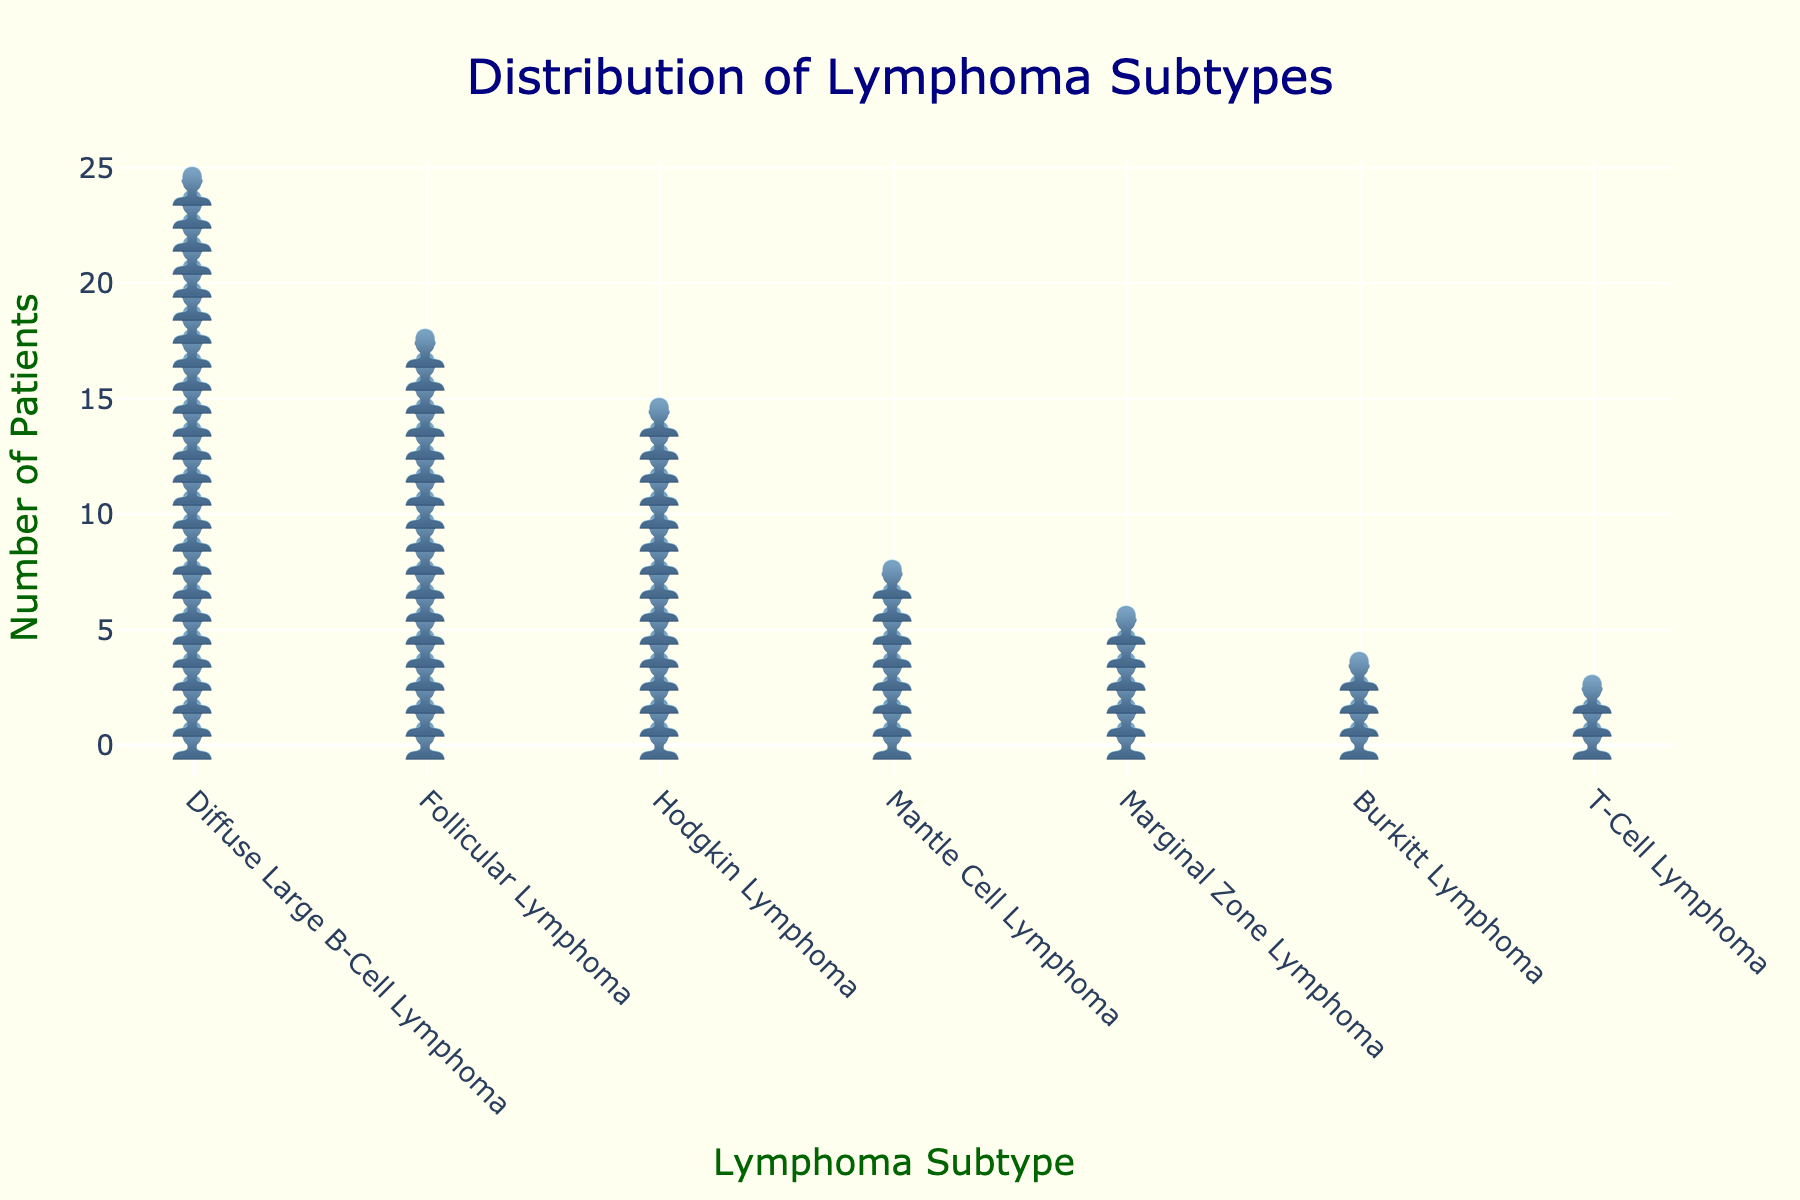What is the most common subtype of lymphoma among patients in the oncology department? The tallest cluster of icons represents the most common subtype. The highest cluster is for Diffuse Large B-Cell Lymphoma.
Answer: Diffuse Large B-Cell Lymphoma How many patients have Follicular Lymphoma? Count the number of icons in the cluster labeled Follicular Lymphoma.
Answer: 18 Compare the number of patients with Mantle Cell Lymphoma to those with Marginal Zone Lymphoma. Which subtype has more patients? Compare the height of the clusters for Mantle Cell Lymphoma and Marginal Zone Lymphoma. The Mantle Cell Lymphoma cluster is taller.
Answer: Mantle Cell Lymphoma Which lymphoma subtype has the least number of patients? Identify the shortest cluster of icons. The shortest cluster corresponds to T-Cell Lymphoma.
Answer: T-Cell Lymphoma How many more patients have Diffuse Large B-Cell Lymphoma than Burkitt Lymphoma? Subtract the number of Burkitt Lymphoma patients from the number of Diffuse Large B-Cell Lymphoma patients (25 - 4).
Answer: 21 Calculate the total number of lymphoma patients represented in the figure. Add the counts of all subtypes (25 + 18 + 15 + 8 + 6 + 4 + 3).
Answer: 79 What is the second most common subtype of lymphoma among the patients? Identify the second tallest cluster of icons. The second tallest cluster corresponds to Follicular Lymphoma.
Answer: Follicular Lymphoma How does the number of Burkitt Lymphoma patients compare to the number of Hodgkin Lymphoma patients? Compare the height of the clusters. The Burkitt Lymphoma cluster is shorter than the Hodgkin Lymphoma cluster.
Answer: Fewer What is the combined total number of patients with Diffuse Large B-Cell Lymphoma and Follicular Lymphoma? Add the counts of patients with Diffuse Large B-Cell Lymphoma and Follicular Lymphoma (25 + 18).
Answer: 43 How many lymphoma subtypes are represented in the figure? Count the number of labeled clusters along the x-axis.
Answer: 7 